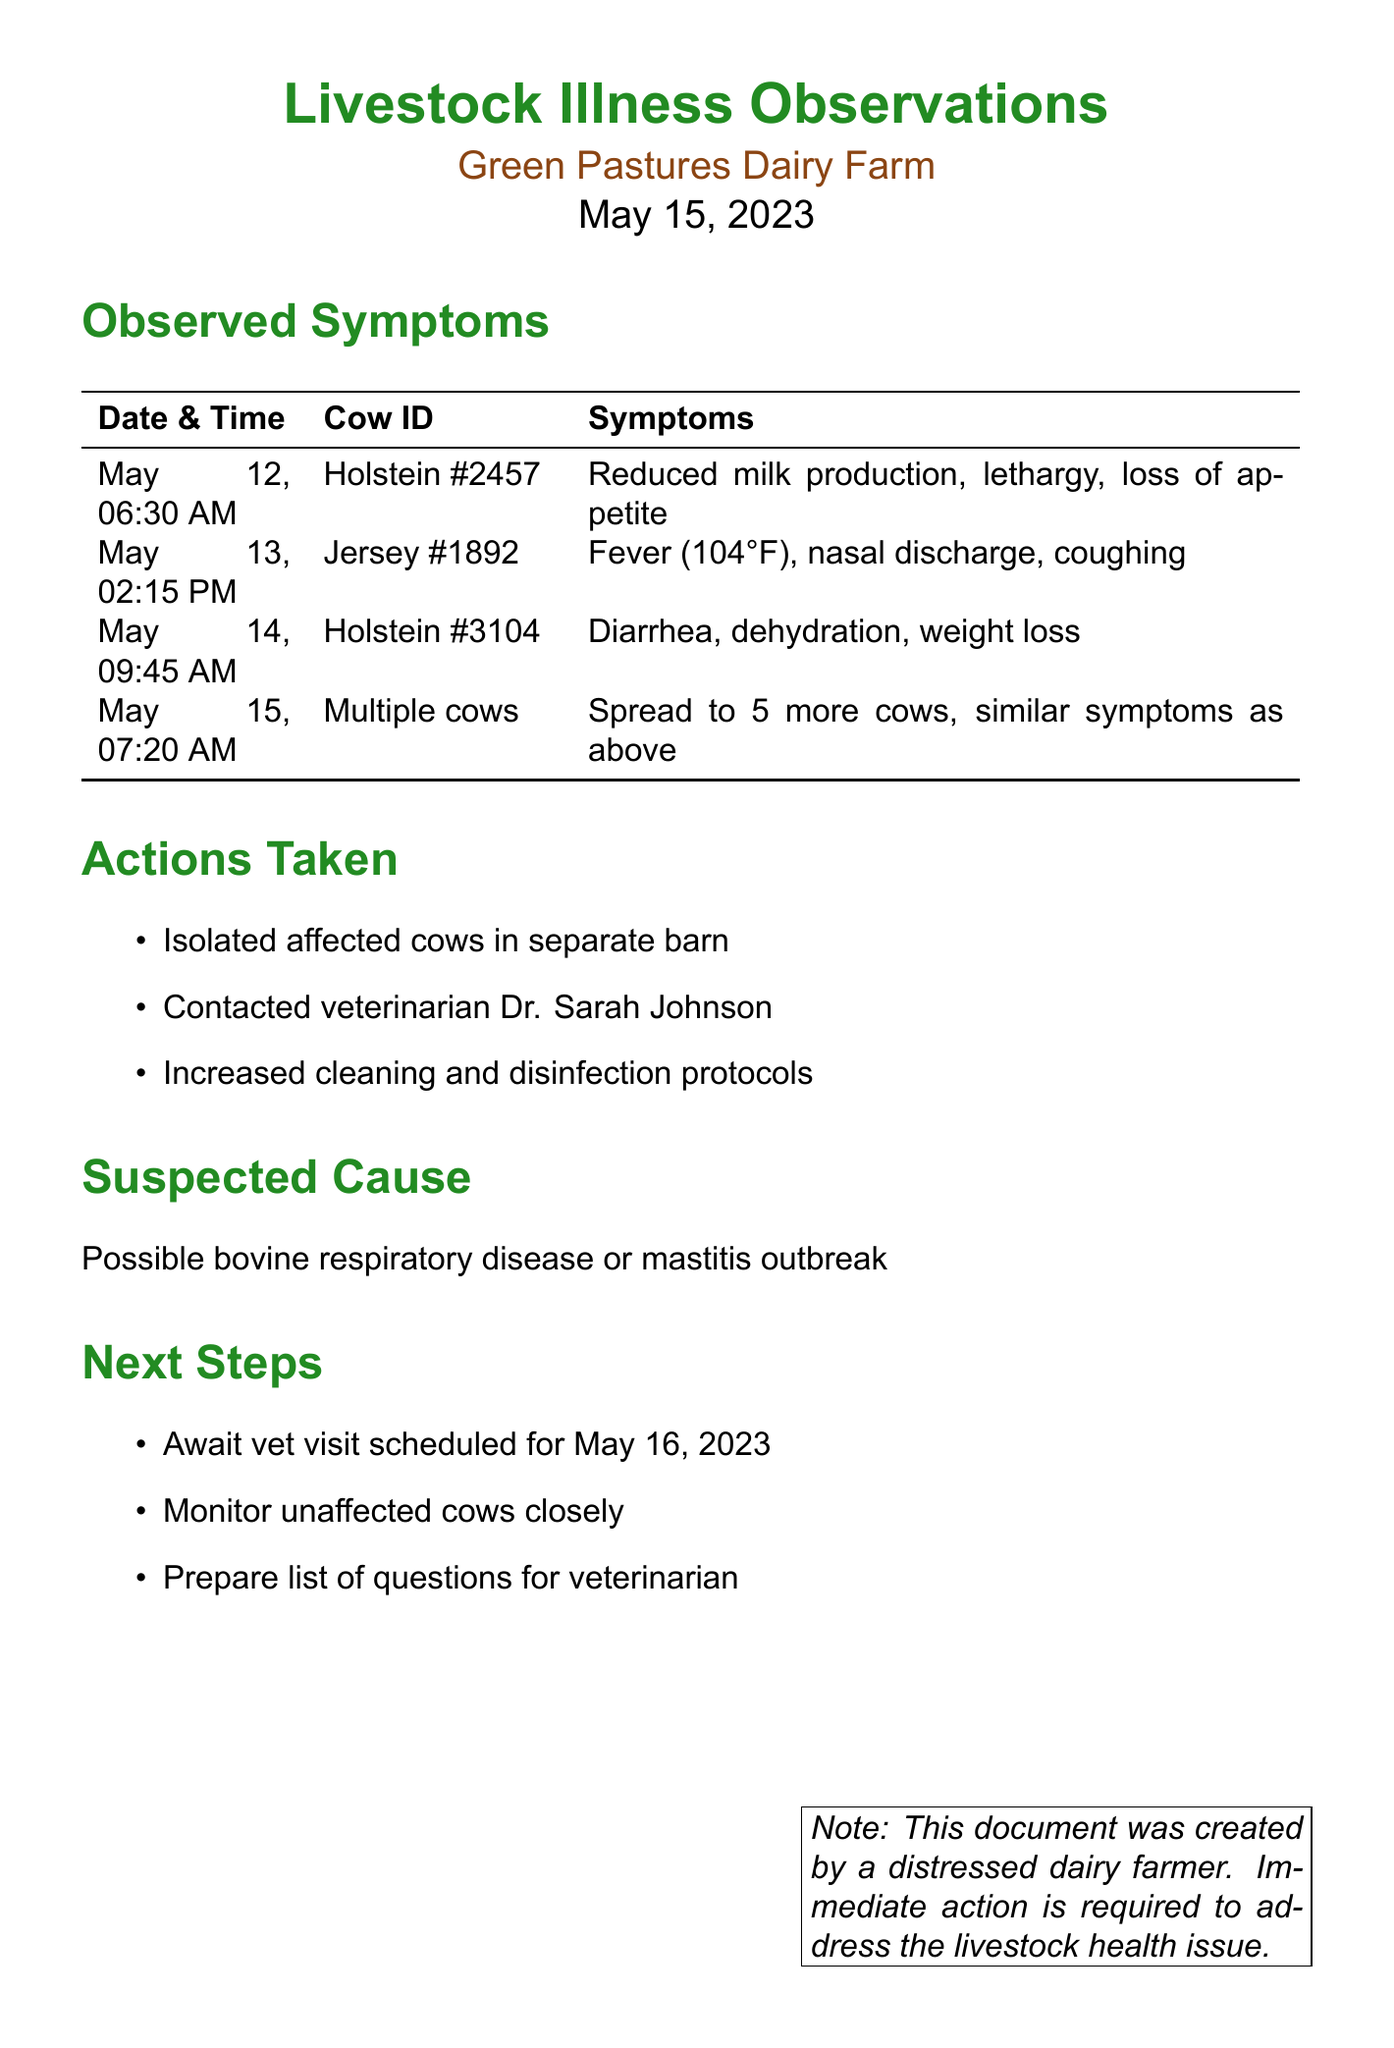What is the name of the farm? The farm name is stated in the title of the document, which is "Green Pastures Dairy Farm."
Answer: Green Pastures Dairy Farm What date was the first observed symptom recorded? The first observed symptom was recorded on May 12, 2023, as indicated in the observations section.
Answer: May 12, 2023 How many cows showed similar symptoms on May 15, 2023? The observation on May 15 indicates that symptoms spread to 5 more cows.
Answer: 5 Who did the farmer contact for help? The actions taken section mentions that the veterinarian contacted was Dr. Sarah Johnson.
Answer: Dr. Sarah Johnson What is the suspected cause of the illness? The suspected cause is mentioned in the suspected cause section, indicating two potential diseases.
Answer: Possible bovine respiratory disease or mastitis outbreak What time was the observation made for Holstein #3104? The observation for Holstein #3104 was made at 09:45 AM on May 14, 2023.
Answer: 09:45 AM What action was taken regarding the sick cows? The actions taken include isolating the affected cows in a separate barn.
Answer: Isolated affected cows in separate barn When is the veterinarian visit scheduled? The next steps section indicates that the vet visit is scheduled for May 16, 2023.
Answer: May 16, 2023 What symptom was observed in Jersey #1892? The symptoms observed in Jersey #1892 include fever, nasal discharge, and coughing.
Answer: Fever (104°F), nasal discharge, coughing 